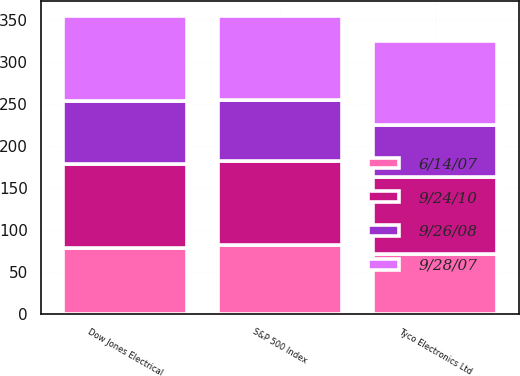Convert chart. <chart><loc_0><loc_0><loc_500><loc_500><stacked_bar_chart><ecel><fcel>Tyco Electronics Ltd<fcel>S&P 500 Index<fcel>Dow Jones Electrical<nl><fcel>9/28/07<fcel>100<fcel>100<fcel>100<nl><fcel>9/24/10<fcel>91.56<fcel>100.77<fcel>99.97<nl><fcel>6/14/07<fcel>71.64<fcel>81.76<fcel>78.08<nl><fcel>9/26/08<fcel>61.15<fcel>72.29<fcel>75.74<nl></chart> 